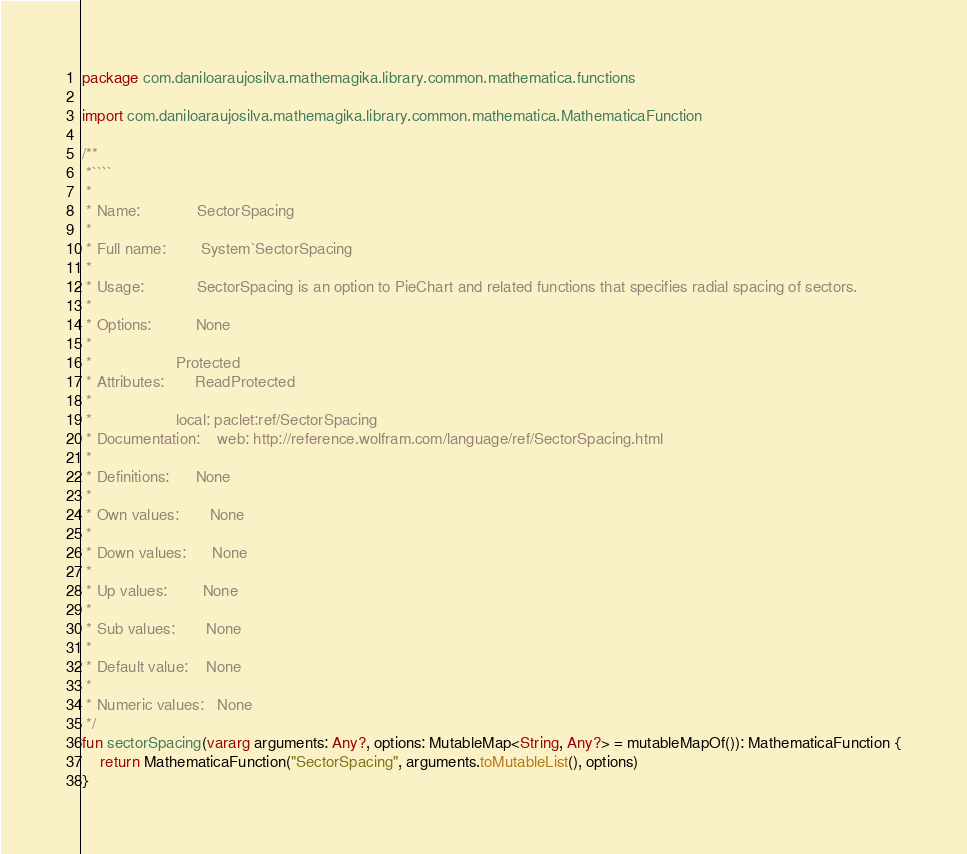<code> <loc_0><loc_0><loc_500><loc_500><_Kotlin_>package com.daniloaraujosilva.mathemagika.library.common.mathematica.functions

import com.daniloaraujosilva.mathemagika.library.common.mathematica.MathematicaFunction

/**
 *````
 *
 * Name:             SectorSpacing
 *
 * Full name:        System`SectorSpacing
 *
 * Usage:            SectorSpacing is an option to PieChart and related functions that specifies radial spacing of sectors.
 *
 * Options:          None
 *
 *                   Protected
 * Attributes:       ReadProtected
 *
 *                   local: paclet:ref/SectorSpacing
 * Documentation:    web: http://reference.wolfram.com/language/ref/SectorSpacing.html
 *
 * Definitions:      None
 *
 * Own values:       None
 *
 * Down values:      None
 *
 * Up values:        None
 *
 * Sub values:       None
 *
 * Default value:    None
 *
 * Numeric values:   None
 */
fun sectorSpacing(vararg arguments: Any?, options: MutableMap<String, Any?> = mutableMapOf()): MathematicaFunction {
	return MathematicaFunction("SectorSpacing", arguments.toMutableList(), options)
}
</code> 